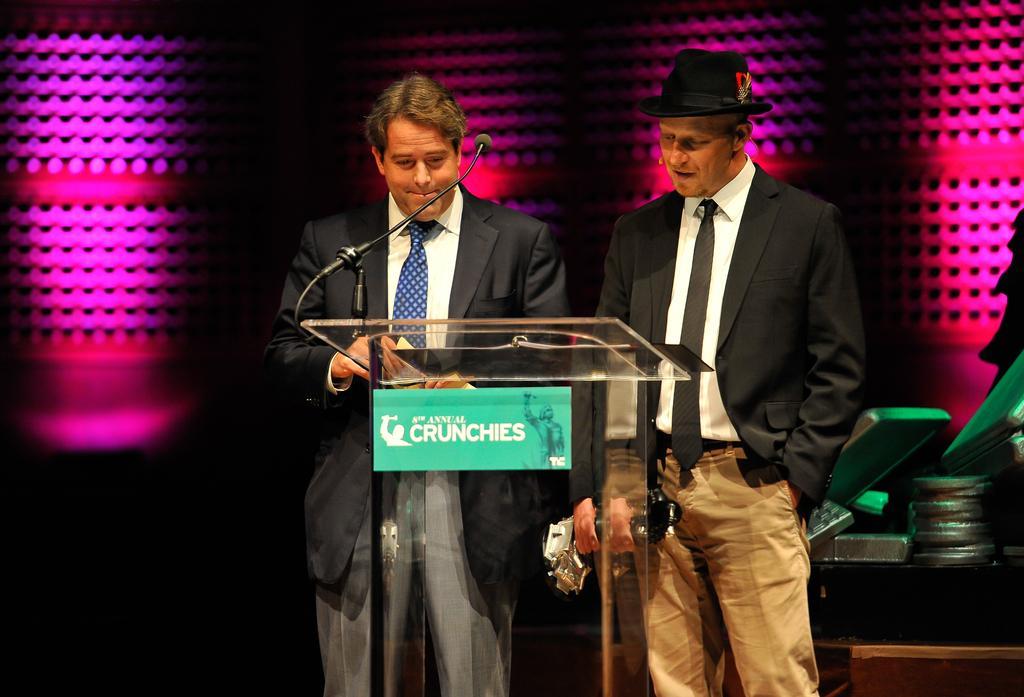In one or two sentences, can you explain what this image depicts? In the foreground of this image, there are two men standing and wearing suits in front of a podium on which there is a mic. In the dark background, there are pink lights and on the right bottom, there are few objects. 